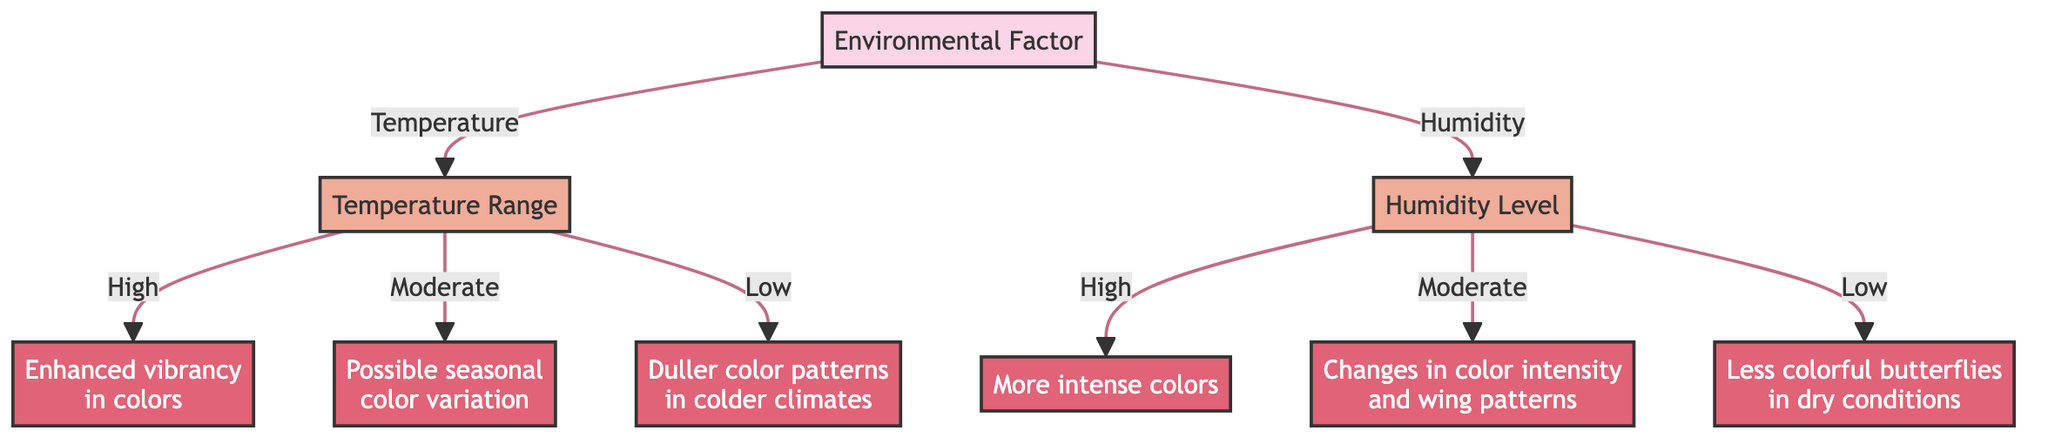What is the root node in the diagram? The root node is the first node that branches out to other nodes, which in this case is "Environmental Factor."
Answer: Environmental Factor How many options are there under the "Temperature Range" node? The "Temperature Range" node presents three options: High, Moderate, and Low.
Answer: 3 Which butterfly species is associated with high temperature? The high temperature leads to the outcome "Enhanced vibrancy in colors" associated with Danaus plexippus.
Answer: Danaus plexippus What happens to coloration patterns at low temperatures? At low temperatures, the outcome is "Duller color patterns observed in colder climates" associated with Celastrina ladon.
Answer: Duller color patterns What outcome is linked to high humidity levels? High humidity levels result in "Presence of more intense colors" associated with Heliconius melpomene.
Answer: More intense colors How many total outcomes are there in the decision tree? The diagram includes five outcomes that result from the different branches of the decision nodes.
Answer: 5 What type of changes are seen in butterfly coloration under moderate humidity? Moderate humidity leads to "Changes in color intensity and wing patterns" as seen in Vanessa cardui.
Answer: Changes in color intensity What is the relationship between "Humidity" and the outcomes? "Humidity" is a decision node that branches into three options (High, Moderate, Low), each leading to different outcomes related to butterfly coloration.
Answer: It branches into outcomes Which butterfly experiences less colorful features in dry conditions? The outcome related to dry conditions states that Pieris rapae shows "Less colorful butterflies."
Answer: Pieris rapae 